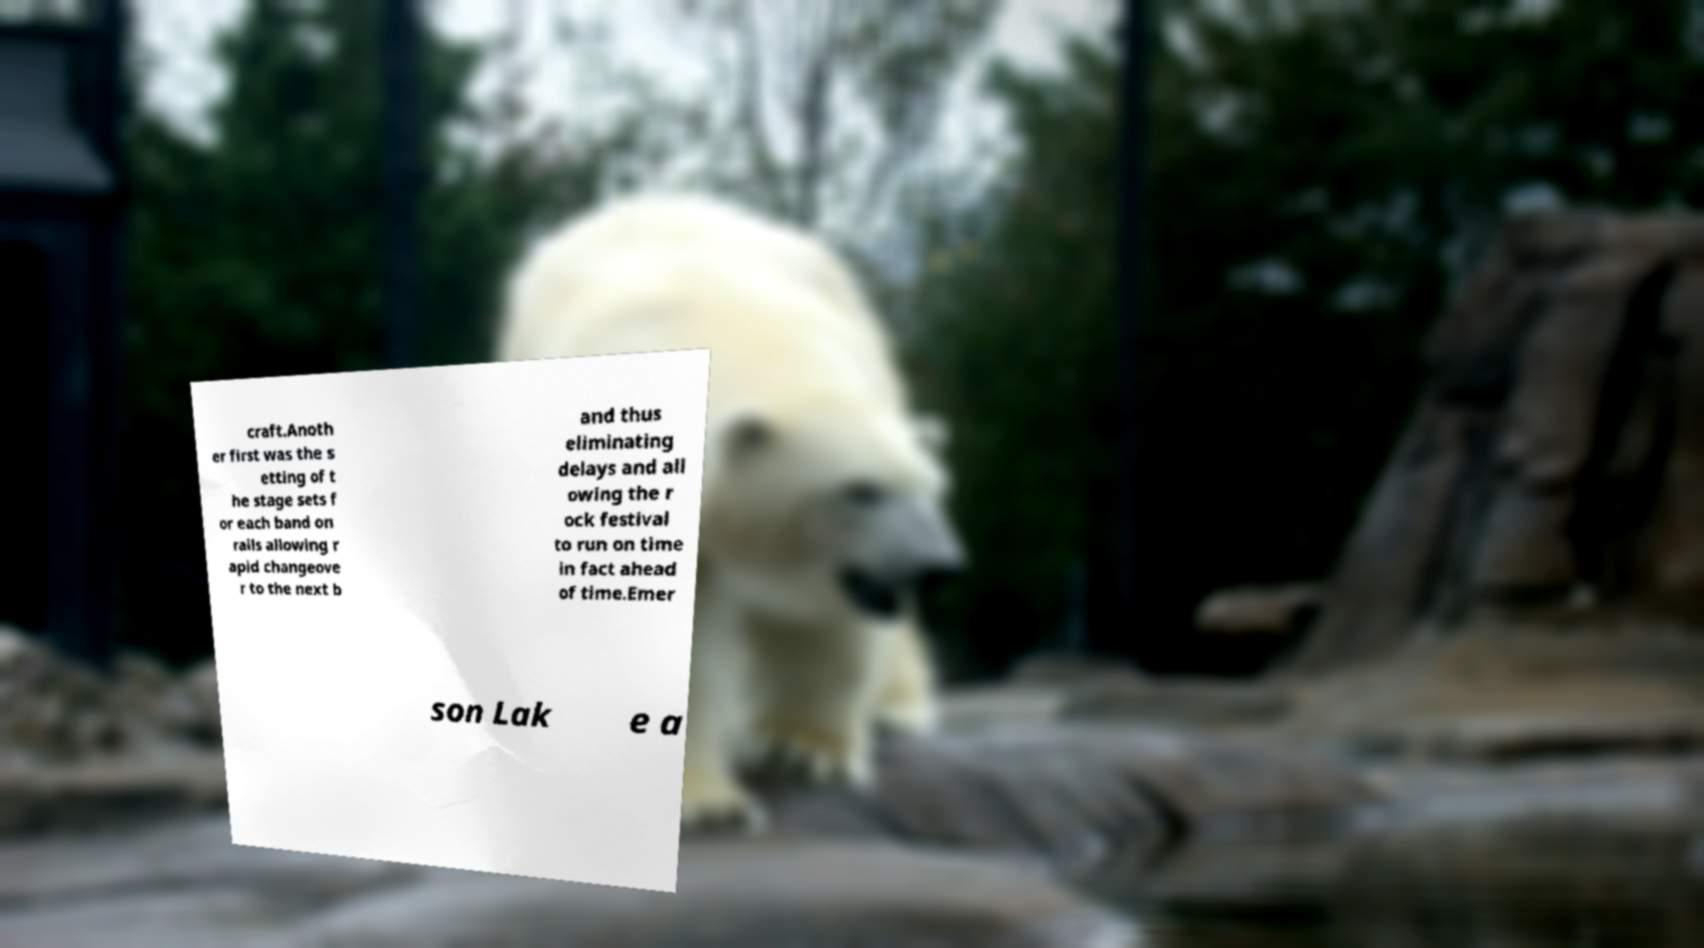I need the written content from this picture converted into text. Can you do that? craft.Anoth er first was the s etting of t he stage sets f or each band on rails allowing r apid changeove r to the next b and thus eliminating delays and all owing the r ock festival to run on time in fact ahead of time.Emer son Lak e a 